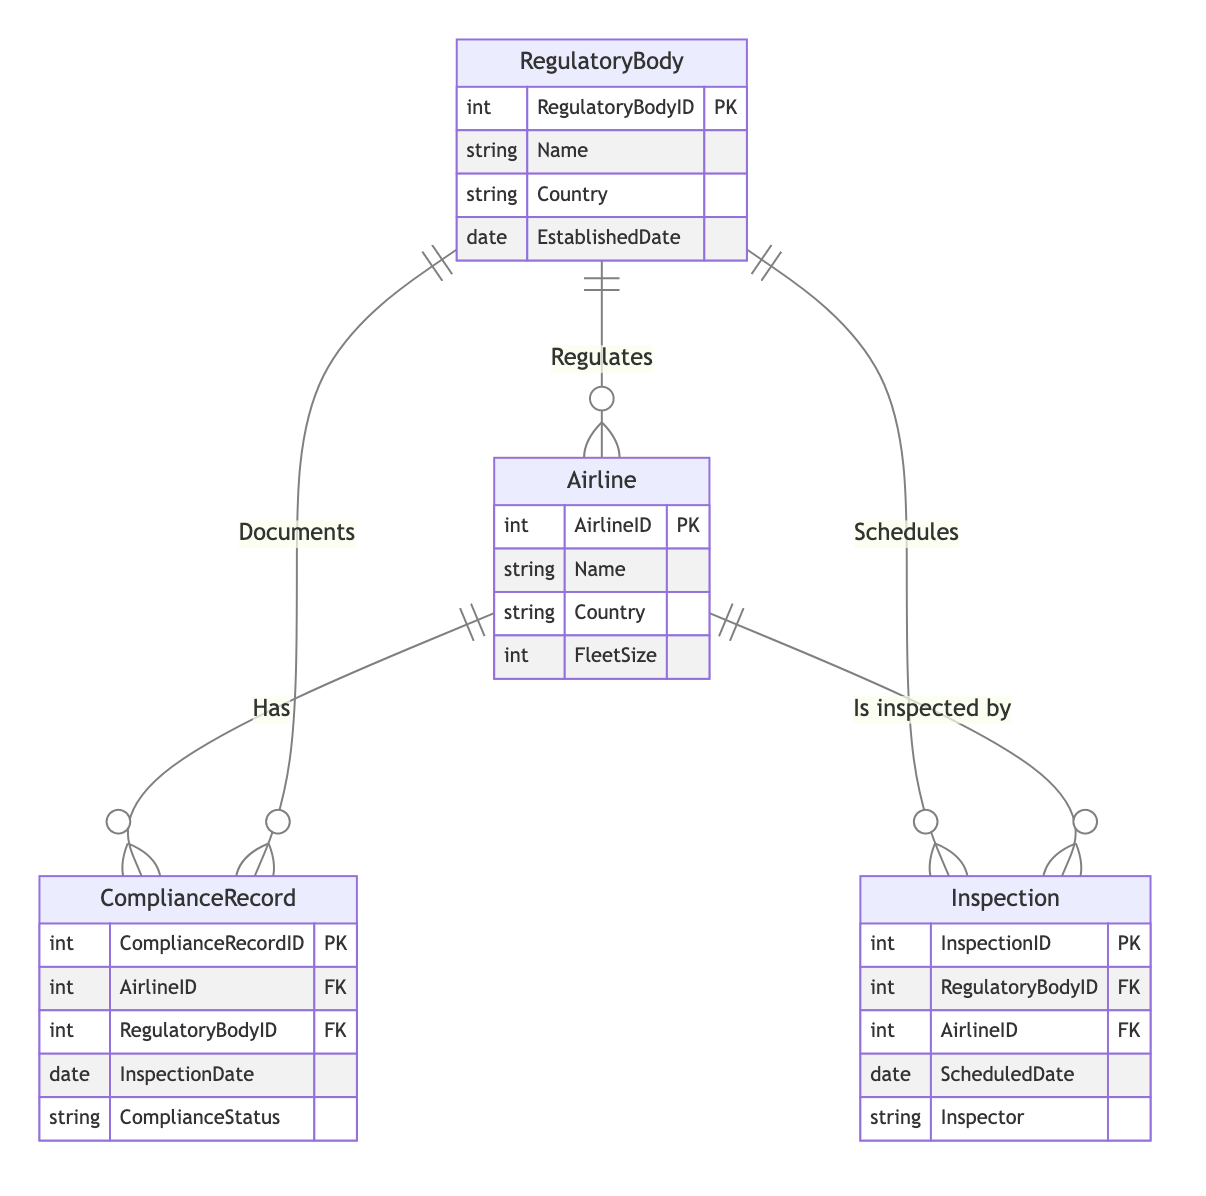What is the primary key of the RegulatoryBody entity? The primary key of the RegulatoryBody entity is RegulatoryBodyID, which uniquely identifies each regulatory body in the system.
Answer: RegulatoryBodyID How many attributes does the Airline entity have? The Airline entity has four attributes: AirlineID, Name, Country, and FleetSize, totaling four.
Answer: Four Which entity has a many-to-one relationship with ComplianceRecord? The ComplianceRecord entity has a many-to-one relationship with both Airline and RegulatoryBody entities as indicated by the relationships defined in the diagram.
Answer: Airline, RegulatoryBody What relationship type connects RegulatoryBody and Airline? The relationship type that connects RegulatoryBody and Airline is "one_to_many" as one regulatory body can regulate multiple airlines.
Answer: One to many What entity is responsible for documenting ComplianceRecords? The RegulatoryBody entity is responsible for documenting ComplianceRecords, as shown by the "Documents" relationship connecting RegulatoryBody and ComplianceRecord.
Answer: RegulatoryBody How many entities are in the diagram? There are four entities in the diagram: RegulatoryBody, Airline, ComplianceRecord, and Inspection.
Answer: Four What does the Inspection entity represent in terms of relationships? The Inspection entity represents scheduled inspections for airlines by regulatory bodies, as indicated by its relationship with both RegulatoryBody and Airline.
Answer: Scheduled inspections Which entity is scheduled by RegulatoryBody? The Inspection entity is scheduled by RegulatoryBody, as shown in the relationship connecting them.
Answer: Inspection What is the maximum number of inspections an airline can have? An airline can have zero or more inspections, as it is connected to the Inspection entity in a many-to-one relationship, meaning each airline can be inspected multiple times by the same or different regulatory bodies.
Answer: Zero or more 